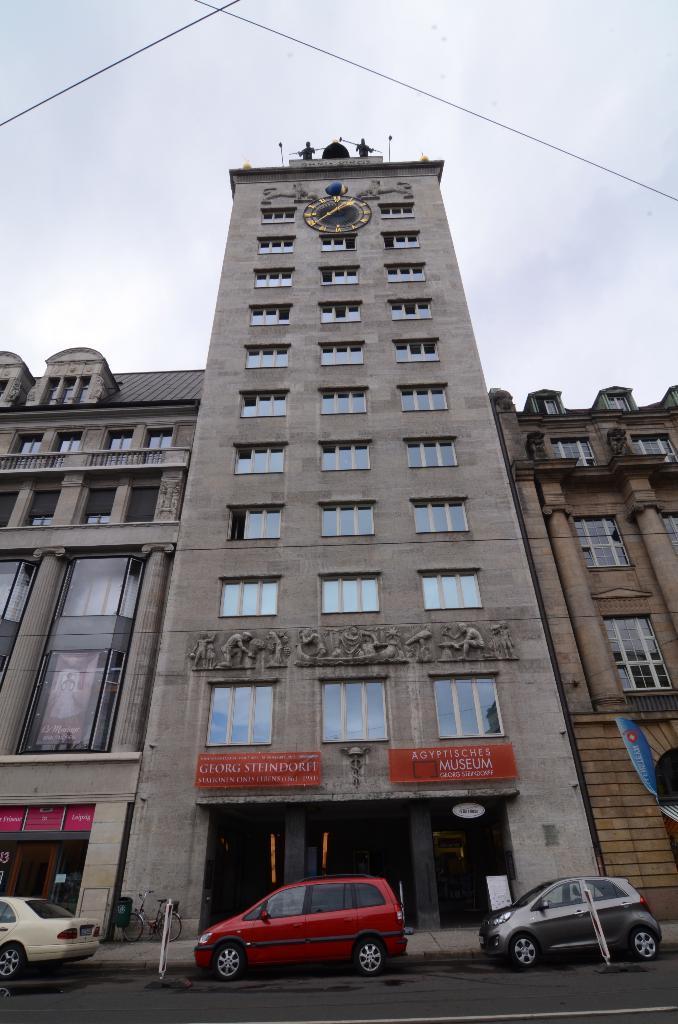How would you summarize this image in a sentence or two? At the bottom there are cars, boards, footpath and road. In the middle of the picture we can see buildings. At the top there are cables and sky. At the top of the building we can see a clock. 